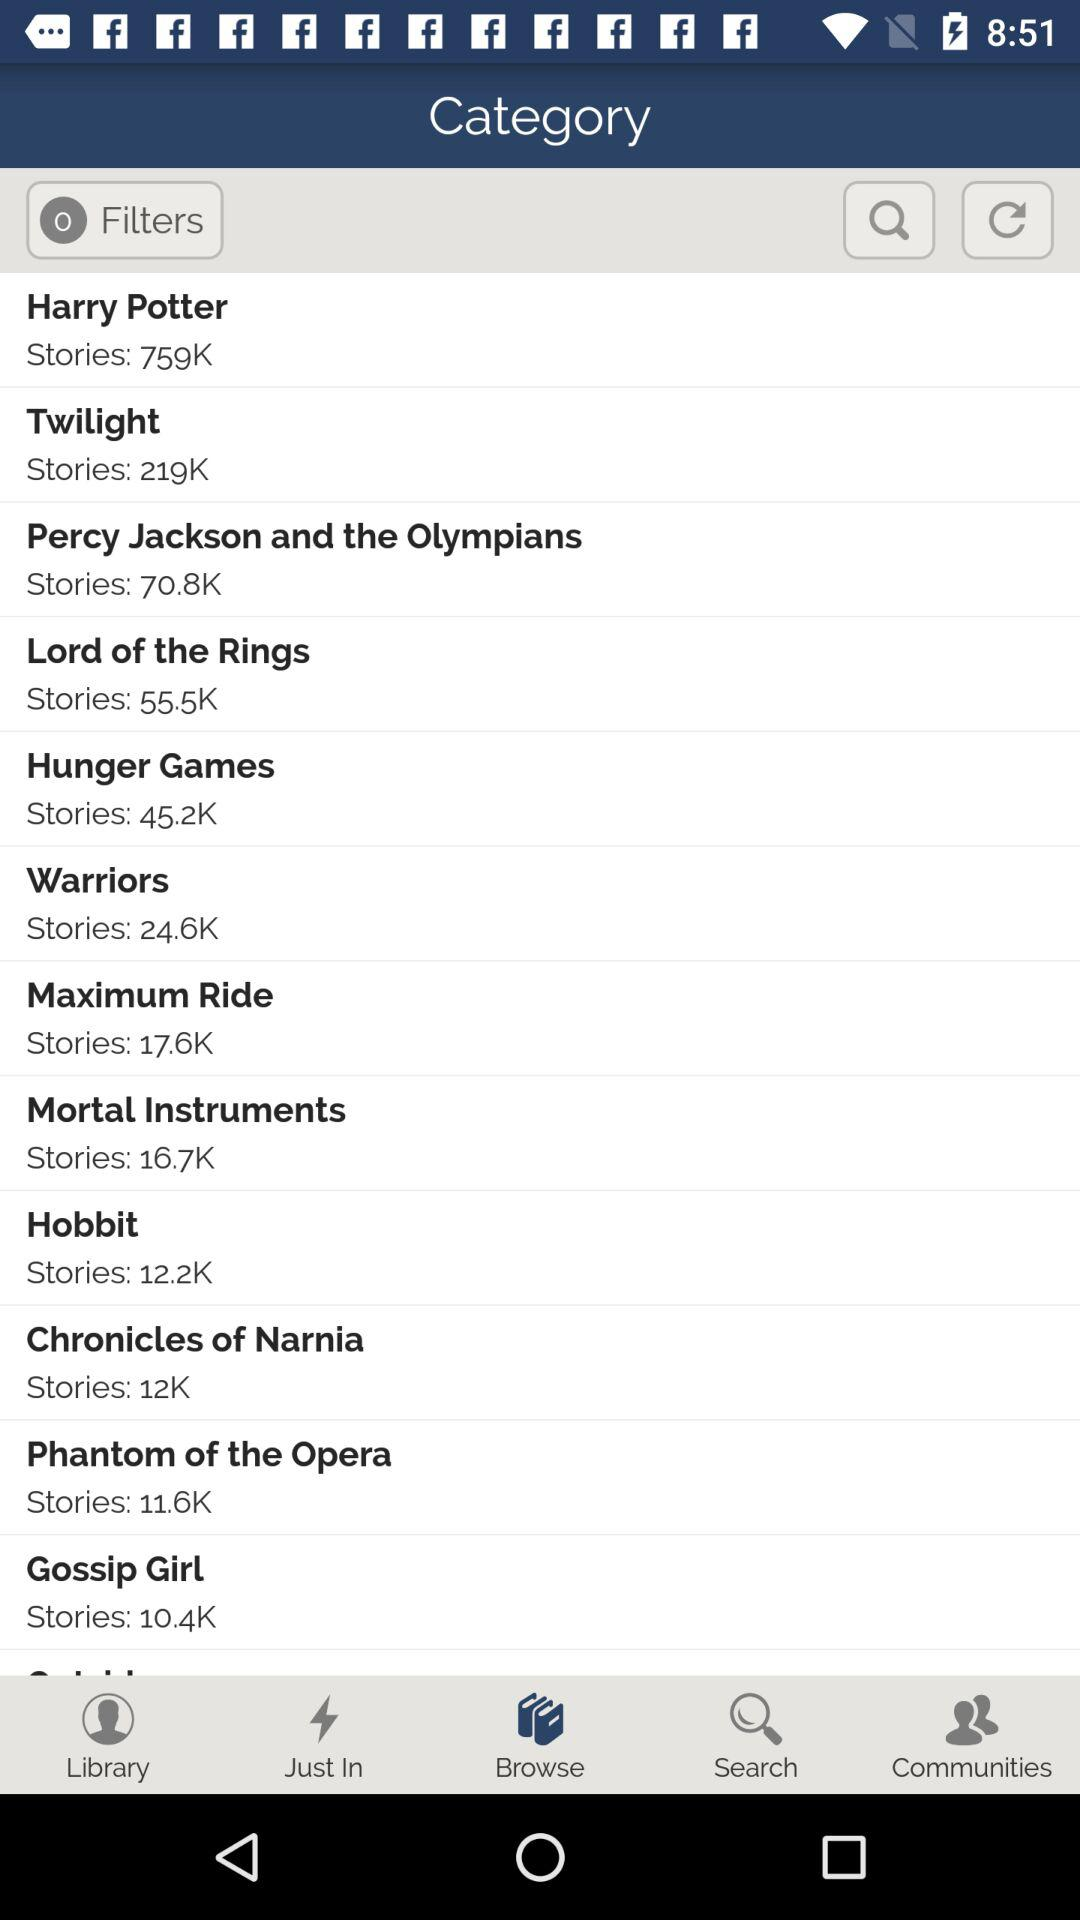How many more stories does the Harry Potter series have than the Twilight series?
Answer the question using a single word or phrase. 540K 